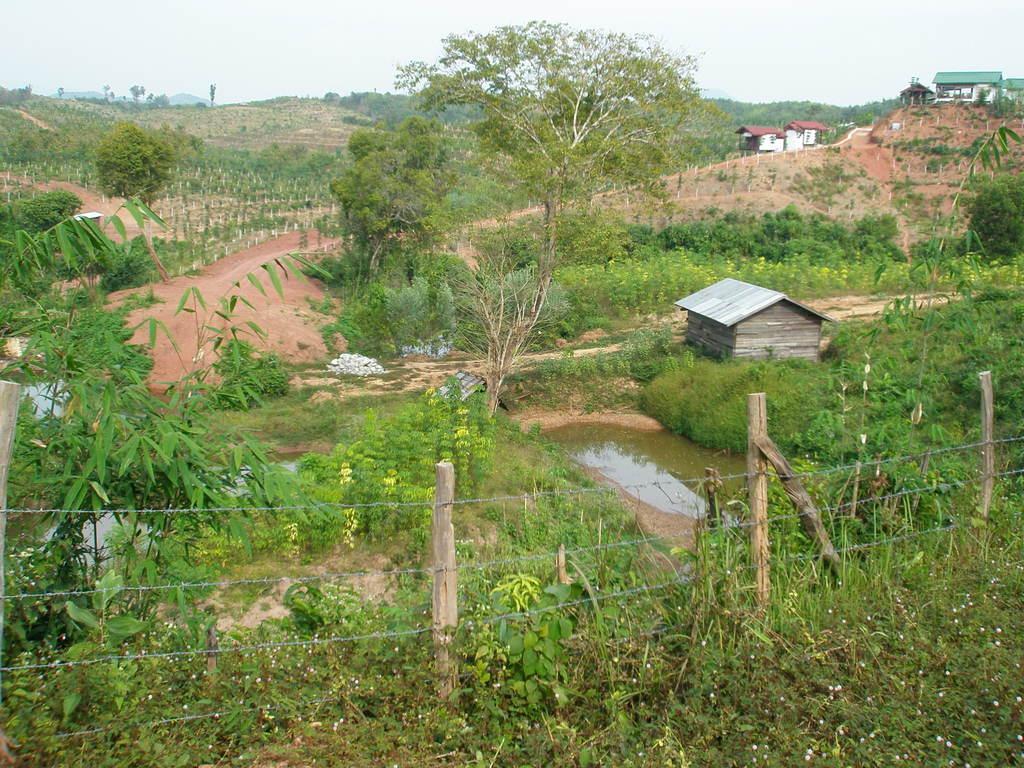Please provide a concise description of this image. In the foreground of the image we can see a fence with poles. In the center of the image we can see a building and a pond with water. In the background, we can see a group of trees, buildings, mountains and the sky. 